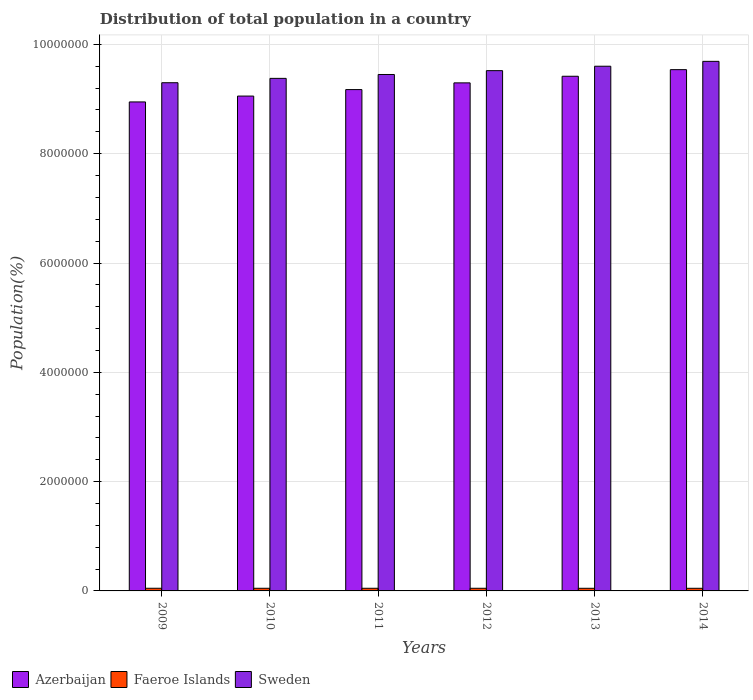How many different coloured bars are there?
Ensure brevity in your answer.  3. Are the number of bars per tick equal to the number of legend labels?
Your response must be concise. Yes. How many bars are there on the 6th tick from the left?
Your response must be concise. 3. How many bars are there on the 6th tick from the right?
Keep it short and to the point. 3. What is the label of the 5th group of bars from the left?
Offer a terse response. 2013. In how many cases, is the number of bars for a given year not equal to the number of legend labels?
Your response must be concise. 0. What is the population of in Sweden in 2010?
Your response must be concise. 9.38e+06. Across all years, what is the maximum population of in Faeroe Islands?
Make the answer very short. 4.86e+04. Across all years, what is the minimum population of in Azerbaijan?
Provide a short and direct response. 8.95e+06. In which year was the population of in Azerbaijan maximum?
Give a very brief answer. 2014. What is the total population of in Sweden in the graph?
Provide a succinct answer. 5.69e+07. What is the difference between the population of in Azerbaijan in 2009 and that in 2012?
Ensure brevity in your answer.  -3.49e+05. What is the difference between the population of in Azerbaijan in 2014 and the population of in Faeroe Islands in 2009?
Make the answer very short. 9.49e+06. What is the average population of in Azerbaijan per year?
Keep it short and to the point. 9.24e+06. In the year 2013, what is the difference between the population of in Sweden and population of in Faeroe Islands?
Offer a very short reply. 9.55e+06. In how many years, is the population of in Faeroe Islands greater than 800000 %?
Make the answer very short. 0. What is the ratio of the population of in Faeroe Islands in 2010 to that in 2011?
Ensure brevity in your answer.  1. Is the difference between the population of in Sweden in 2009 and 2010 greater than the difference between the population of in Faeroe Islands in 2009 and 2010?
Provide a short and direct response. No. What is the difference between the highest and the second highest population of in Faeroe Islands?
Provide a succinct answer. 46. What is the difference between the highest and the lowest population of in Azerbaijan?
Ensure brevity in your answer.  5.91e+05. What does the 2nd bar from the left in 2012 represents?
Provide a short and direct response. Faeroe Islands. What does the 2nd bar from the right in 2013 represents?
Ensure brevity in your answer.  Faeroe Islands. How many bars are there?
Your response must be concise. 18. Are all the bars in the graph horizontal?
Offer a terse response. No. What is the difference between two consecutive major ticks on the Y-axis?
Keep it short and to the point. 2.00e+06. Are the values on the major ticks of Y-axis written in scientific E-notation?
Make the answer very short. No. Does the graph contain any zero values?
Give a very brief answer. No. Where does the legend appear in the graph?
Provide a short and direct response. Bottom left. How many legend labels are there?
Provide a short and direct response. 3. How are the legend labels stacked?
Your response must be concise. Horizontal. What is the title of the graph?
Ensure brevity in your answer.  Distribution of total population in a country. Does "Guinea" appear as one of the legend labels in the graph?
Ensure brevity in your answer.  No. What is the label or title of the Y-axis?
Your answer should be very brief. Population(%). What is the Population(%) in Azerbaijan in 2009?
Your answer should be compact. 8.95e+06. What is the Population(%) of Faeroe Islands in 2009?
Offer a terse response. 4.86e+04. What is the Population(%) of Sweden in 2009?
Your answer should be compact. 9.30e+06. What is the Population(%) of Azerbaijan in 2010?
Offer a terse response. 9.05e+06. What is the Population(%) of Faeroe Islands in 2010?
Offer a very short reply. 4.86e+04. What is the Population(%) in Sweden in 2010?
Give a very brief answer. 9.38e+06. What is the Population(%) in Azerbaijan in 2011?
Keep it short and to the point. 9.17e+06. What is the Population(%) of Faeroe Islands in 2011?
Your answer should be compact. 4.85e+04. What is the Population(%) in Sweden in 2011?
Your response must be concise. 9.45e+06. What is the Population(%) of Azerbaijan in 2012?
Your response must be concise. 9.30e+06. What is the Population(%) in Faeroe Islands in 2012?
Provide a short and direct response. 4.84e+04. What is the Population(%) of Sweden in 2012?
Keep it short and to the point. 9.52e+06. What is the Population(%) of Azerbaijan in 2013?
Keep it short and to the point. 9.42e+06. What is the Population(%) in Faeroe Islands in 2013?
Give a very brief answer. 4.83e+04. What is the Population(%) of Sweden in 2013?
Your answer should be very brief. 9.60e+06. What is the Population(%) of Azerbaijan in 2014?
Your answer should be compact. 9.54e+06. What is the Population(%) in Faeroe Islands in 2014?
Ensure brevity in your answer.  4.82e+04. What is the Population(%) of Sweden in 2014?
Your answer should be very brief. 9.69e+06. Across all years, what is the maximum Population(%) in Azerbaijan?
Give a very brief answer. 9.54e+06. Across all years, what is the maximum Population(%) of Faeroe Islands?
Keep it short and to the point. 4.86e+04. Across all years, what is the maximum Population(%) of Sweden?
Your answer should be very brief. 9.69e+06. Across all years, what is the minimum Population(%) of Azerbaijan?
Provide a succinct answer. 8.95e+06. Across all years, what is the minimum Population(%) in Faeroe Islands?
Provide a succinct answer. 4.82e+04. Across all years, what is the minimum Population(%) in Sweden?
Provide a short and direct response. 9.30e+06. What is the total Population(%) in Azerbaijan in the graph?
Give a very brief answer. 5.54e+07. What is the total Population(%) of Faeroe Islands in the graph?
Offer a very short reply. 2.91e+05. What is the total Population(%) of Sweden in the graph?
Give a very brief answer. 5.69e+07. What is the difference between the Population(%) in Azerbaijan in 2009 and that in 2010?
Your answer should be compact. -1.07e+05. What is the difference between the Population(%) in Faeroe Islands in 2009 and that in 2010?
Provide a short and direct response. 46. What is the difference between the Population(%) of Sweden in 2009 and that in 2010?
Your answer should be very brief. -7.96e+04. What is the difference between the Population(%) of Azerbaijan in 2009 and that in 2011?
Make the answer very short. -2.26e+05. What is the difference between the Population(%) of Faeroe Islands in 2009 and that in 2011?
Your answer should be compact. 121. What is the difference between the Population(%) in Sweden in 2009 and that in 2011?
Your answer should be very brief. -1.51e+05. What is the difference between the Population(%) in Azerbaijan in 2009 and that in 2012?
Your answer should be compact. -3.49e+05. What is the difference between the Population(%) in Faeroe Islands in 2009 and that in 2012?
Make the answer very short. 220. What is the difference between the Population(%) in Sweden in 2009 and that in 2012?
Offer a terse response. -2.21e+05. What is the difference between the Population(%) of Azerbaijan in 2009 and that in 2013?
Offer a very short reply. -4.70e+05. What is the difference between the Population(%) of Faeroe Islands in 2009 and that in 2013?
Provide a succinct answer. 321. What is the difference between the Population(%) in Sweden in 2009 and that in 2013?
Offer a terse response. -3.02e+05. What is the difference between the Population(%) of Azerbaijan in 2009 and that in 2014?
Provide a short and direct response. -5.91e+05. What is the difference between the Population(%) in Faeroe Islands in 2009 and that in 2014?
Your response must be concise. 392. What is the difference between the Population(%) in Sweden in 2009 and that in 2014?
Your answer should be compact. -3.91e+05. What is the difference between the Population(%) in Azerbaijan in 2010 and that in 2011?
Provide a succinct answer. -1.19e+05. What is the difference between the Population(%) of Sweden in 2010 and that in 2011?
Your answer should be compact. -7.11e+04. What is the difference between the Population(%) in Azerbaijan in 2010 and that in 2012?
Provide a succinct answer. -2.41e+05. What is the difference between the Population(%) in Faeroe Islands in 2010 and that in 2012?
Offer a very short reply. 174. What is the difference between the Population(%) in Sweden in 2010 and that in 2012?
Your answer should be compact. -1.41e+05. What is the difference between the Population(%) in Azerbaijan in 2010 and that in 2013?
Ensure brevity in your answer.  -3.62e+05. What is the difference between the Population(%) of Faeroe Islands in 2010 and that in 2013?
Give a very brief answer. 275. What is the difference between the Population(%) in Sweden in 2010 and that in 2013?
Your answer should be very brief. -2.22e+05. What is the difference between the Population(%) of Azerbaijan in 2010 and that in 2014?
Give a very brief answer. -4.83e+05. What is the difference between the Population(%) of Faeroe Islands in 2010 and that in 2014?
Provide a short and direct response. 346. What is the difference between the Population(%) of Sweden in 2010 and that in 2014?
Give a very brief answer. -3.11e+05. What is the difference between the Population(%) of Azerbaijan in 2011 and that in 2012?
Provide a short and direct response. -1.23e+05. What is the difference between the Population(%) of Sweden in 2011 and that in 2012?
Give a very brief answer. -7.02e+04. What is the difference between the Population(%) in Azerbaijan in 2011 and that in 2013?
Your response must be concise. -2.44e+05. What is the difference between the Population(%) of Faeroe Islands in 2011 and that in 2013?
Provide a short and direct response. 200. What is the difference between the Population(%) in Sweden in 2011 and that in 2013?
Provide a short and direct response. -1.51e+05. What is the difference between the Population(%) of Azerbaijan in 2011 and that in 2014?
Keep it short and to the point. -3.65e+05. What is the difference between the Population(%) in Faeroe Islands in 2011 and that in 2014?
Provide a succinct answer. 271. What is the difference between the Population(%) in Sweden in 2011 and that in 2014?
Keep it short and to the point. -2.40e+05. What is the difference between the Population(%) of Azerbaijan in 2012 and that in 2013?
Your response must be concise. -1.21e+05. What is the difference between the Population(%) in Faeroe Islands in 2012 and that in 2013?
Offer a very short reply. 101. What is the difference between the Population(%) in Sweden in 2012 and that in 2013?
Give a very brief answer. -8.10e+04. What is the difference between the Population(%) in Azerbaijan in 2012 and that in 2014?
Your response must be concise. -2.42e+05. What is the difference between the Population(%) of Faeroe Islands in 2012 and that in 2014?
Offer a terse response. 172. What is the difference between the Population(%) of Sweden in 2012 and that in 2014?
Your answer should be very brief. -1.70e+05. What is the difference between the Population(%) in Azerbaijan in 2013 and that in 2014?
Provide a succinct answer. -1.21e+05. What is the difference between the Population(%) in Sweden in 2013 and that in 2014?
Ensure brevity in your answer.  -8.92e+04. What is the difference between the Population(%) of Azerbaijan in 2009 and the Population(%) of Faeroe Islands in 2010?
Provide a succinct answer. 8.90e+06. What is the difference between the Population(%) in Azerbaijan in 2009 and the Population(%) in Sweden in 2010?
Ensure brevity in your answer.  -4.31e+05. What is the difference between the Population(%) of Faeroe Islands in 2009 and the Population(%) of Sweden in 2010?
Provide a short and direct response. -9.33e+06. What is the difference between the Population(%) of Azerbaijan in 2009 and the Population(%) of Faeroe Islands in 2011?
Offer a terse response. 8.90e+06. What is the difference between the Population(%) of Azerbaijan in 2009 and the Population(%) of Sweden in 2011?
Your answer should be very brief. -5.02e+05. What is the difference between the Population(%) of Faeroe Islands in 2009 and the Population(%) of Sweden in 2011?
Your answer should be very brief. -9.40e+06. What is the difference between the Population(%) of Azerbaijan in 2009 and the Population(%) of Faeroe Islands in 2012?
Make the answer very short. 8.90e+06. What is the difference between the Population(%) in Azerbaijan in 2009 and the Population(%) in Sweden in 2012?
Provide a succinct answer. -5.72e+05. What is the difference between the Population(%) in Faeroe Islands in 2009 and the Population(%) in Sweden in 2012?
Provide a short and direct response. -9.47e+06. What is the difference between the Population(%) in Azerbaijan in 2009 and the Population(%) in Faeroe Islands in 2013?
Your answer should be very brief. 8.90e+06. What is the difference between the Population(%) in Azerbaijan in 2009 and the Population(%) in Sweden in 2013?
Provide a short and direct response. -6.53e+05. What is the difference between the Population(%) of Faeroe Islands in 2009 and the Population(%) of Sweden in 2013?
Offer a terse response. -9.55e+06. What is the difference between the Population(%) in Azerbaijan in 2009 and the Population(%) in Faeroe Islands in 2014?
Your answer should be compact. 8.90e+06. What is the difference between the Population(%) of Azerbaijan in 2009 and the Population(%) of Sweden in 2014?
Keep it short and to the point. -7.42e+05. What is the difference between the Population(%) of Faeroe Islands in 2009 and the Population(%) of Sweden in 2014?
Your answer should be very brief. -9.64e+06. What is the difference between the Population(%) in Azerbaijan in 2010 and the Population(%) in Faeroe Islands in 2011?
Your answer should be compact. 9.01e+06. What is the difference between the Population(%) in Azerbaijan in 2010 and the Population(%) in Sweden in 2011?
Provide a short and direct response. -3.95e+05. What is the difference between the Population(%) in Faeroe Islands in 2010 and the Population(%) in Sweden in 2011?
Provide a short and direct response. -9.40e+06. What is the difference between the Population(%) in Azerbaijan in 2010 and the Population(%) in Faeroe Islands in 2012?
Provide a succinct answer. 9.01e+06. What is the difference between the Population(%) of Azerbaijan in 2010 and the Population(%) of Sweden in 2012?
Offer a very short reply. -4.65e+05. What is the difference between the Population(%) in Faeroe Islands in 2010 and the Population(%) in Sweden in 2012?
Your response must be concise. -9.47e+06. What is the difference between the Population(%) of Azerbaijan in 2010 and the Population(%) of Faeroe Islands in 2013?
Your answer should be compact. 9.01e+06. What is the difference between the Population(%) in Azerbaijan in 2010 and the Population(%) in Sweden in 2013?
Your answer should be compact. -5.46e+05. What is the difference between the Population(%) in Faeroe Islands in 2010 and the Population(%) in Sweden in 2013?
Your answer should be compact. -9.55e+06. What is the difference between the Population(%) in Azerbaijan in 2010 and the Population(%) in Faeroe Islands in 2014?
Provide a short and direct response. 9.01e+06. What is the difference between the Population(%) of Azerbaijan in 2010 and the Population(%) of Sweden in 2014?
Your answer should be compact. -6.35e+05. What is the difference between the Population(%) of Faeroe Islands in 2010 and the Population(%) of Sweden in 2014?
Offer a terse response. -9.64e+06. What is the difference between the Population(%) in Azerbaijan in 2011 and the Population(%) in Faeroe Islands in 2012?
Make the answer very short. 9.12e+06. What is the difference between the Population(%) in Azerbaijan in 2011 and the Population(%) in Sweden in 2012?
Your answer should be very brief. -3.46e+05. What is the difference between the Population(%) in Faeroe Islands in 2011 and the Population(%) in Sweden in 2012?
Give a very brief answer. -9.47e+06. What is the difference between the Population(%) in Azerbaijan in 2011 and the Population(%) in Faeroe Islands in 2013?
Your answer should be compact. 9.12e+06. What is the difference between the Population(%) of Azerbaijan in 2011 and the Population(%) of Sweden in 2013?
Your answer should be compact. -4.27e+05. What is the difference between the Population(%) of Faeroe Islands in 2011 and the Population(%) of Sweden in 2013?
Make the answer very short. -9.55e+06. What is the difference between the Population(%) in Azerbaijan in 2011 and the Population(%) in Faeroe Islands in 2014?
Provide a succinct answer. 9.12e+06. What is the difference between the Population(%) in Azerbaijan in 2011 and the Population(%) in Sweden in 2014?
Keep it short and to the point. -5.16e+05. What is the difference between the Population(%) of Faeroe Islands in 2011 and the Population(%) of Sweden in 2014?
Your answer should be compact. -9.64e+06. What is the difference between the Population(%) in Azerbaijan in 2012 and the Population(%) in Faeroe Islands in 2013?
Your response must be concise. 9.25e+06. What is the difference between the Population(%) in Azerbaijan in 2012 and the Population(%) in Sweden in 2013?
Keep it short and to the point. -3.05e+05. What is the difference between the Population(%) of Faeroe Islands in 2012 and the Population(%) of Sweden in 2013?
Your answer should be compact. -9.55e+06. What is the difference between the Population(%) in Azerbaijan in 2012 and the Population(%) in Faeroe Islands in 2014?
Provide a short and direct response. 9.25e+06. What is the difference between the Population(%) of Azerbaijan in 2012 and the Population(%) of Sweden in 2014?
Offer a very short reply. -3.94e+05. What is the difference between the Population(%) of Faeroe Islands in 2012 and the Population(%) of Sweden in 2014?
Make the answer very short. -9.64e+06. What is the difference between the Population(%) of Azerbaijan in 2013 and the Population(%) of Faeroe Islands in 2014?
Make the answer very short. 9.37e+06. What is the difference between the Population(%) in Azerbaijan in 2013 and the Population(%) in Sweden in 2014?
Ensure brevity in your answer.  -2.73e+05. What is the difference between the Population(%) in Faeroe Islands in 2013 and the Population(%) in Sweden in 2014?
Make the answer very short. -9.64e+06. What is the average Population(%) in Azerbaijan per year?
Offer a very short reply. 9.24e+06. What is the average Population(%) of Faeroe Islands per year?
Your answer should be compact. 4.84e+04. What is the average Population(%) in Sweden per year?
Provide a succinct answer. 9.49e+06. In the year 2009, what is the difference between the Population(%) in Azerbaijan and Population(%) in Faeroe Islands?
Keep it short and to the point. 8.90e+06. In the year 2009, what is the difference between the Population(%) of Azerbaijan and Population(%) of Sweden?
Give a very brief answer. -3.51e+05. In the year 2009, what is the difference between the Population(%) of Faeroe Islands and Population(%) of Sweden?
Keep it short and to the point. -9.25e+06. In the year 2010, what is the difference between the Population(%) in Azerbaijan and Population(%) in Faeroe Islands?
Offer a terse response. 9.01e+06. In the year 2010, what is the difference between the Population(%) in Azerbaijan and Population(%) in Sweden?
Ensure brevity in your answer.  -3.24e+05. In the year 2010, what is the difference between the Population(%) of Faeroe Islands and Population(%) of Sweden?
Offer a very short reply. -9.33e+06. In the year 2011, what is the difference between the Population(%) of Azerbaijan and Population(%) of Faeroe Islands?
Offer a very short reply. 9.12e+06. In the year 2011, what is the difference between the Population(%) in Azerbaijan and Population(%) in Sweden?
Your answer should be compact. -2.76e+05. In the year 2011, what is the difference between the Population(%) of Faeroe Islands and Population(%) of Sweden?
Your answer should be very brief. -9.40e+06. In the year 2012, what is the difference between the Population(%) in Azerbaijan and Population(%) in Faeroe Islands?
Offer a terse response. 9.25e+06. In the year 2012, what is the difference between the Population(%) of Azerbaijan and Population(%) of Sweden?
Ensure brevity in your answer.  -2.24e+05. In the year 2012, what is the difference between the Population(%) in Faeroe Islands and Population(%) in Sweden?
Your answer should be very brief. -9.47e+06. In the year 2013, what is the difference between the Population(%) in Azerbaijan and Population(%) in Faeroe Islands?
Your answer should be compact. 9.37e+06. In the year 2013, what is the difference between the Population(%) in Azerbaijan and Population(%) in Sweden?
Offer a very short reply. -1.84e+05. In the year 2013, what is the difference between the Population(%) of Faeroe Islands and Population(%) of Sweden?
Make the answer very short. -9.55e+06. In the year 2014, what is the difference between the Population(%) in Azerbaijan and Population(%) in Faeroe Islands?
Provide a succinct answer. 9.49e+06. In the year 2014, what is the difference between the Population(%) of Azerbaijan and Population(%) of Sweden?
Give a very brief answer. -1.52e+05. In the year 2014, what is the difference between the Population(%) in Faeroe Islands and Population(%) in Sweden?
Offer a very short reply. -9.64e+06. What is the ratio of the Population(%) in Faeroe Islands in 2009 to that in 2010?
Give a very brief answer. 1. What is the ratio of the Population(%) in Azerbaijan in 2009 to that in 2011?
Your response must be concise. 0.98. What is the ratio of the Population(%) in Sweden in 2009 to that in 2011?
Keep it short and to the point. 0.98. What is the ratio of the Population(%) of Azerbaijan in 2009 to that in 2012?
Keep it short and to the point. 0.96. What is the ratio of the Population(%) in Faeroe Islands in 2009 to that in 2012?
Make the answer very short. 1. What is the ratio of the Population(%) of Sweden in 2009 to that in 2012?
Your response must be concise. 0.98. What is the ratio of the Population(%) of Azerbaijan in 2009 to that in 2013?
Ensure brevity in your answer.  0.95. What is the ratio of the Population(%) of Faeroe Islands in 2009 to that in 2013?
Give a very brief answer. 1.01. What is the ratio of the Population(%) in Sweden in 2009 to that in 2013?
Offer a very short reply. 0.97. What is the ratio of the Population(%) of Azerbaijan in 2009 to that in 2014?
Ensure brevity in your answer.  0.94. What is the ratio of the Population(%) in Faeroe Islands in 2009 to that in 2014?
Keep it short and to the point. 1.01. What is the ratio of the Population(%) of Sweden in 2009 to that in 2014?
Make the answer very short. 0.96. What is the ratio of the Population(%) of Azerbaijan in 2010 to that in 2011?
Your answer should be very brief. 0.99. What is the ratio of the Population(%) of Azerbaijan in 2010 to that in 2012?
Your response must be concise. 0.97. What is the ratio of the Population(%) of Faeroe Islands in 2010 to that in 2012?
Give a very brief answer. 1. What is the ratio of the Population(%) of Sweden in 2010 to that in 2012?
Offer a very short reply. 0.99. What is the ratio of the Population(%) in Azerbaijan in 2010 to that in 2013?
Make the answer very short. 0.96. What is the ratio of the Population(%) in Faeroe Islands in 2010 to that in 2013?
Your answer should be very brief. 1.01. What is the ratio of the Population(%) in Sweden in 2010 to that in 2013?
Offer a very short reply. 0.98. What is the ratio of the Population(%) of Azerbaijan in 2010 to that in 2014?
Ensure brevity in your answer.  0.95. What is the ratio of the Population(%) of Faeroe Islands in 2010 to that in 2014?
Your answer should be compact. 1.01. What is the ratio of the Population(%) of Sweden in 2010 to that in 2014?
Make the answer very short. 0.97. What is the ratio of the Population(%) in Azerbaijan in 2011 to that in 2012?
Offer a very short reply. 0.99. What is the ratio of the Population(%) of Sweden in 2011 to that in 2012?
Provide a succinct answer. 0.99. What is the ratio of the Population(%) in Azerbaijan in 2011 to that in 2013?
Offer a terse response. 0.97. What is the ratio of the Population(%) in Faeroe Islands in 2011 to that in 2013?
Provide a short and direct response. 1. What is the ratio of the Population(%) of Sweden in 2011 to that in 2013?
Your answer should be compact. 0.98. What is the ratio of the Population(%) of Azerbaijan in 2011 to that in 2014?
Provide a short and direct response. 0.96. What is the ratio of the Population(%) in Faeroe Islands in 2011 to that in 2014?
Make the answer very short. 1.01. What is the ratio of the Population(%) in Sweden in 2011 to that in 2014?
Ensure brevity in your answer.  0.98. What is the ratio of the Population(%) in Azerbaijan in 2012 to that in 2013?
Provide a succinct answer. 0.99. What is the ratio of the Population(%) in Azerbaijan in 2012 to that in 2014?
Make the answer very short. 0.97. What is the ratio of the Population(%) of Sweden in 2012 to that in 2014?
Provide a short and direct response. 0.98. What is the ratio of the Population(%) of Azerbaijan in 2013 to that in 2014?
Provide a succinct answer. 0.99. What is the ratio of the Population(%) of Faeroe Islands in 2013 to that in 2014?
Keep it short and to the point. 1. What is the ratio of the Population(%) of Sweden in 2013 to that in 2014?
Provide a succinct answer. 0.99. What is the difference between the highest and the second highest Population(%) in Azerbaijan?
Give a very brief answer. 1.21e+05. What is the difference between the highest and the second highest Population(%) of Sweden?
Offer a very short reply. 8.92e+04. What is the difference between the highest and the lowest Population(%) of Azerbaijan?
Offer a very short reply. 5.91e+05. What is the difference between the highest and the lowest Population(%) in Faeroe Islands?
Your answer should be very brief. 392. What is the difference between the highest and the lowest Population(%) of Sweden?
Your answer should be very brief. 3.91e+05. 